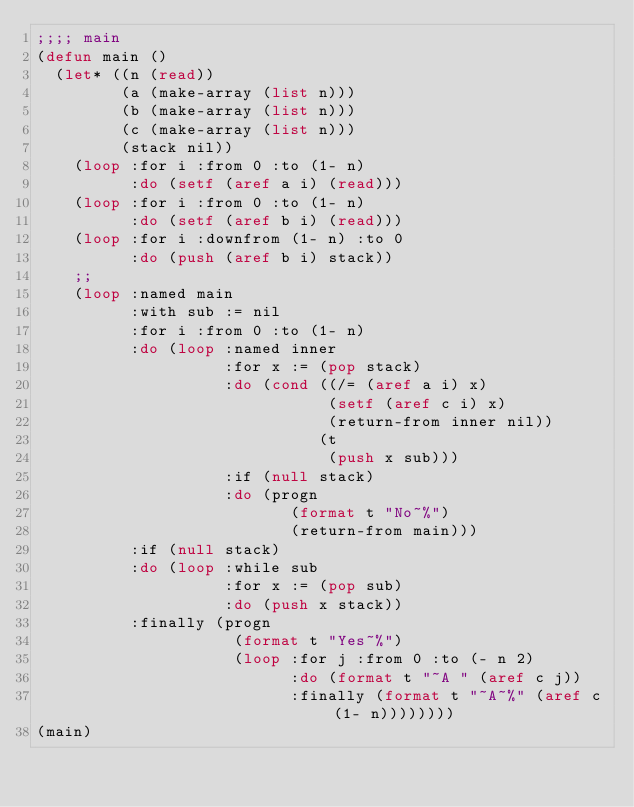Convert code to text. <code><loc_0><loc_0><loc_500><loc_500><_Lisp_>;;;; main
(defun main ()
  (let* ((n (read))
         (a (make-array (list n)))
         (b (make-array (list n)))
         (c (make-array (list n)))
         (stack nil))
    (loop :for i :from 0 :to (1- n)
          :do (setf (aref a i) (read)))
    (loop :for i :from 0 :to (1- n)
          :do (setf (aref b i) (read)))
    (loop :for i :downfrom (1- n) :to 0
          :do (push (aref b i) stack))
    ;;
    (loop :named main
          :with sub := nil
          :for i :from 0 :to (1- n)
          :do (loop :named inner
                    :for x := (pop stack)
                    :do (cond ((/= (aref a i) x)
                               (setf (aref c i) x)
                               (return-from inner nil))
                              (t
                               (push x sub)))
                    :if (null stack)
                    :do (progn
                           (format t "No~%")
                           (return-from main)))
          :if (null stack)
          :do (loop :while sub
                    :for x := (pop sub)
                    :do (push x stack))
          :finally (progn
                     (format t "Yes~%")
                     (loop :for j :from 0 :to (- n 2)
                           :do (format t "~A " (aref c j))
                           :finally (format t "~A~%" (aref c (1- n))))))))
(main)
</code> 